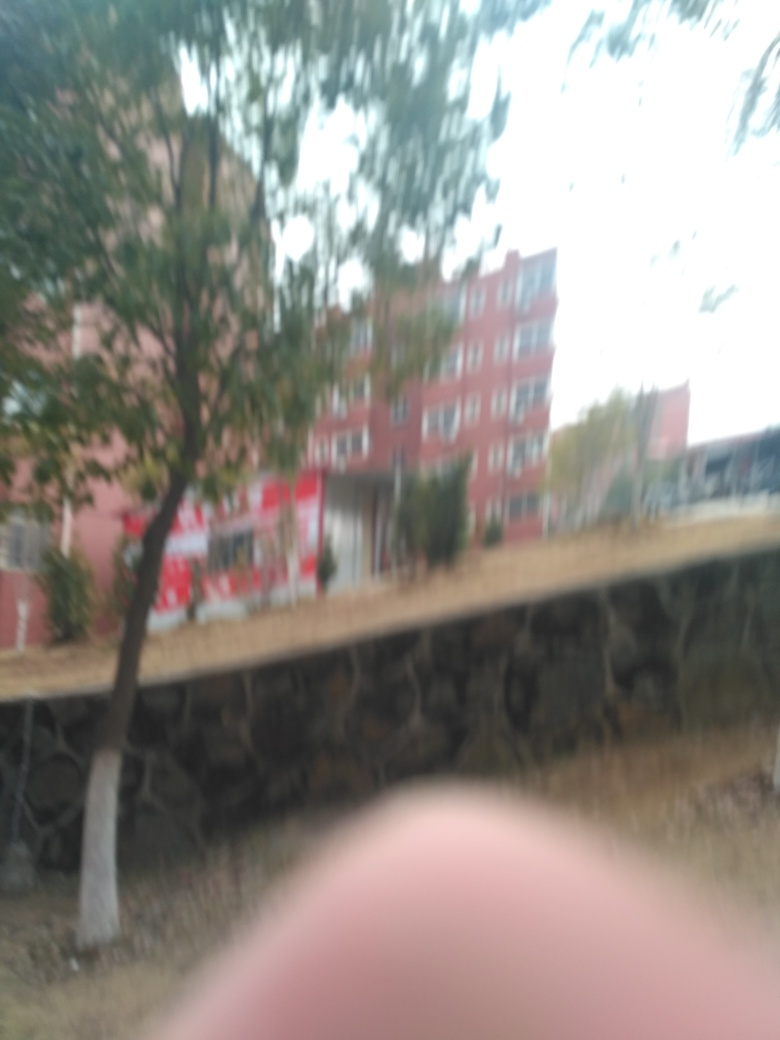Can you tell what might have caused the blurriness in this image? The blurriness in the image could be due to several factors such as camera movement while the photo was being taken, the autofocus malfunctioning, or an incorrect camera setting like a slow shutter speed, which isn't suitable for handheld photography. 